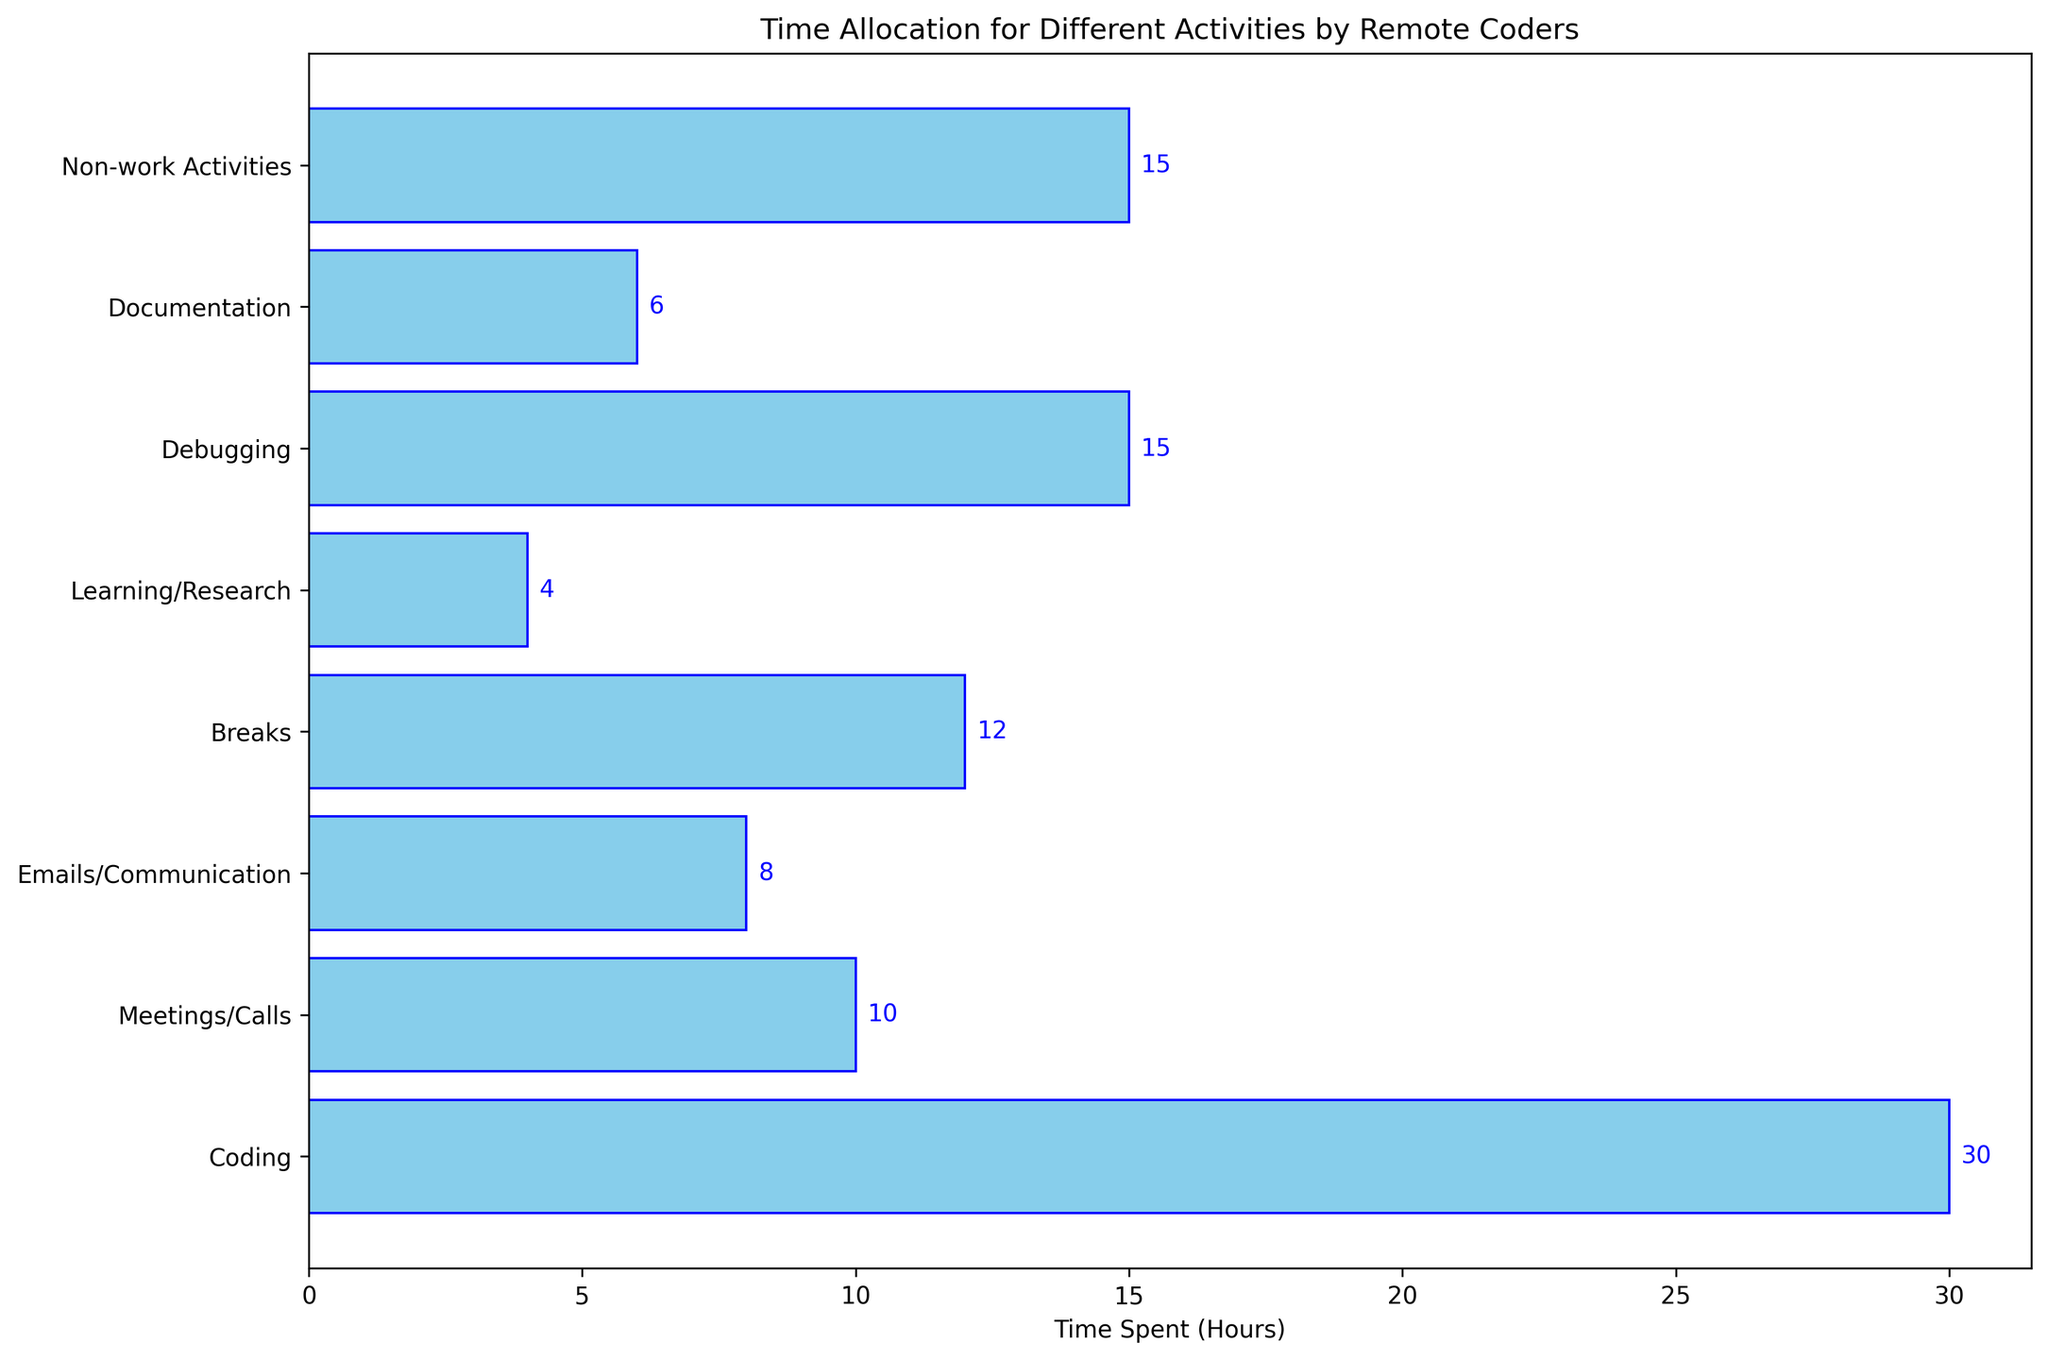What's the total time spent on Coding, Debugging, and Documentation combined? Add the time spent on each of these activities: Coding (30 hours), Debugging (15 hours), and Documentation (6 hours). 30 + 15 + 6 = 51 hours.
Answer: 51 hours Which activity has the least amount of time spent? By looking at the bar lengths, we see that the bar for Learning/Research is the shortest, which means it has the least time spent.
Answer: Learning/Research How much more time is spent on Meetings/Calls compared to Learning/Research? Subtract the time spent on Learning/Research (4 hours) from the time spent on Meetings/Calls (10 hours). 10 - 4 = 6 hours.
Answer: 6 hours Which two activities have the same amount of time allocated to them? Both Debugging and Non-work Activities have bars of equal length, each showing 15 hours.
Answer: Debugging and Non-work Activities What is the average time spent on Breaks and Emails/Communication? Add the time spent on Breaks (12 hours) and Emails/Communication (8 hours), then divide by 2 for the average. (12 + 8) / 2 = 10 hours.
Answer: 10 hours Compare the time spent on Coding to the time spent on Non-work Activities, which one is greater and by how much? Subtract the time spent on Non-work Activities (15 hours) from the time spent on Coding (30 hours). 30 - 15 = 15 hours. Coding has more time spent by 15 hours.
Answer: Coding by 15 hours Which activity takes up more time: Debugging or Documentation, and by how many hours? Subtract the time spent on Documentation (6 hours) from the time spent on Debugging (15 hours). 15 - 6 = 9 hours. Debugging takes up more time by 9 hours.
Answer: Debugging by 9 hours What's the second most time-consuming activity? By looking at the bar lengths, Coding is the most time-consuming at 30 hours, and the second longest bar is Debugging at 15 hours.
Answer: Debugging What's the combined time spent on Meetings/Calls and Breaks compared to the time spent on Coding? Combine the time spent on Meetings/Calls (10 hours) and Breaks (12 hours) to get 22 hours, then compare it to Coding which is 30 hours. 30 - 22 = 8 hours more for Coding.
Answer: 8 hours more for Coding Which activity has a time allocation closest to that of Documentation? Breaks have a time close to Documentation, with Documentation at 6 hours and Breaks at 12 hours, making it the next closest time allocation.
Answer: Documentation and Breaks 